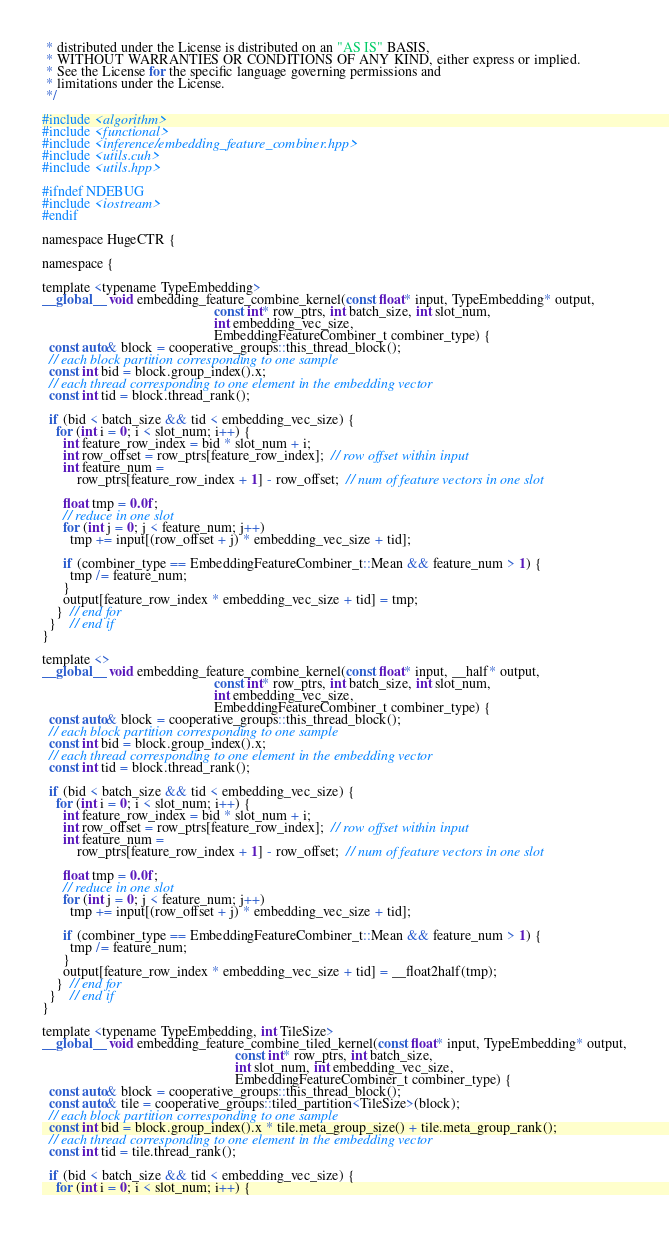<code> <loc_0><loc_0><loc_500><loc_500><_Cuda_> * distributed under the License is distributed on an "AS IS" BASIS,
 * WITHOUT WARRANTIES OR CONDITIONS OF ANY KIND, either express or implied.
 * See the License for the specific language governing permissions and
 * limitations under the License.
 */

#include <algorithm>
#include <functional>
#include <inference/embedding_feature_combiner.hpp>
#include <utils.cuh>
#include <utils.hpp>

#ifndef NDEBUG
#include <iostream>
#endif

namespace HugeCTR {

namespace {

template <typename TypeEmbedding>
__global__ void embedding_feature_combine_kernel(const float* input, TypeEmbedding* output,
                                                 const int* row_ptrs, int batch_size, int slot_num,
                                                 int embedding_vec_size,
                                                 EmbeddingFeatureCombiner_t combiner_type) {
  const auto& block = cooperative_groups::this_thread_block();
  // each block partition corresponding to one sample
  const int bid = block.group_index().x;
  // each thread corresponding to one element in the embedding vector
  const int tid = block.thread_rank();

  if (bid < batch_size && tid < embedding_vec_size) {
    for (int i = 0; i < slot_num; i++) {
      int feature_row_index = bid * slot_num + i;
      int row_offset = row_ptrs[feature_row_index];  // row offset within input
      int feature_num =
          row_ptrs[feature_row_index + 1] - row_offset;  // num of feature vectors in one slot

      float tmp = 0.0f;
      // reduce in one slot
      for (int j = 0; j < feature_num; j++)
        tmp += input[(row_offset + j) * embedding_vec_size + tid];

      if (combiner_type == EmbeddingFeatureCombiner_t::Mean && feature_num > 1) {
        tmp /= feature_num;
      }
      output[feature_row_index * embedding_vec_size + tid] = tmp;
    }  // end for
  }    // end if
}

template <>
__global__ void embedding_feature_combine_kernel(const float* input, __half* output,
                                                 const int* row_ptrs, int batch_size, int slot_num,
                                                 int embedding_vec_size,
                                                 EmbeddingFeatureCombiner_t combiner_type) {
  const auto& block = cooperative_groups::this_thread_block();
  // each block partition corresponding to one sample
  const int bid = block.group_index().x;
  // each thread corresponding to one element in the embedding vector
  const int tid = block.thread_rank();

  if (bid < batch_size && tid < embedding_vec_size) {
    for (int i = 0; i < slot_num; i++) {
      int feature_row_index = bid * slot_num + i;
      int row_offset = row_ptrs[feature_row_index];  // row offset within input
      int feature_num =
          row_ptrs[feature_row_index + 1] - row_offset;  // num of feature vectors in one slot

      float tmp = 0.0f;
      // reduce in one slot
      for (int j = 0; j < feature_num; j++)
        tmp += input[(row_offset + j) * embedding_vec_size + tid];

      if (combiner_type == EmbeddingFeatureCombiner_t::Mean && feature_num > 1) {
        tmp /= feature_num;
      }
      output[feature_row_index * embedding_vec_size + tid] = __float2half(tmp);
    }  // end for
  }    // end if
}

template <typename TypeEmbedding, int TileSize>
__global__ void embedding_feature_combine_tiled_kernel(const float* input, TypeEmbedding* output,
                                                       const int* row_ptrs, int batch_size,
                                                       int slot_num, int embedding_vec_size,
                                                       EmbeddingFeatureCombiner_t combiner_type) {
  const auto& block = cooperative_groups::this_thread_block();
  const auto& tile = cooperative_groups::tiled_partition<TileSize>(block);
  // each block partition corresponding to one sample
  const int bid = block.group_index().x * tile.meta_group_size() + tile.meta_group_rank();
  // each thread corresponding to one element in the embedding vector
  const int tid = tile.thread_rank();

  if (bid < batch_size && tid < embedding_vec_size) {
    for (int i = 0; i < slot_num; i++) {</code> 